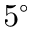<formula> <loc_0><loc_0><loc_500><loc_500>5 ^ { \circ }</formula> 